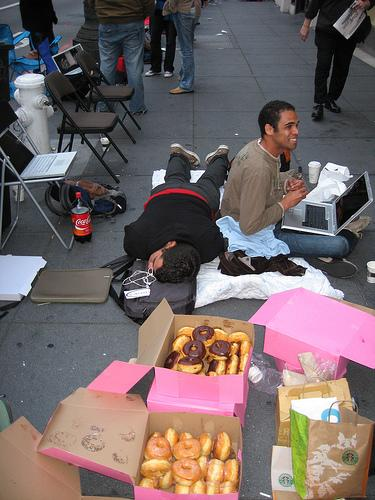How many donuts with chocolate topping are there in the image? There are six donuts with chocolate topping visible in the image. Describe the bag near the man on the sidewalk and what is on it. There is a brown paper bag near the man on the sidewalk, and it has a Starbucks label on it. What kind of device is the man sitting cross-legged using? The man sitting cross-legged is using a laptop. Identify the location and the unusual occurrence involving a man in this image. A man is seen sleeping face down on the sidewalk, which is an unusual occurrence. What type of beverage is in the brown paper sack? The brown paper sack has a Starbucks label on it, indicating that it likely contains a Starbucks beverage. What is the color and type of chair in the image, and what is placed on it? There is a black folding chair with a laptop sitting on it. Mention the color and content of the two boxes on the ground. There are two pink boxes on the ground, containing glazed and chocolate donuts. Comment on the condition of the Coca Cola bottle in the image. The Coca Cola bottle in the image is partially drank, indicating that it has been opened and consumed. What type of object is laying on the sidewalk with a gray color? A gray laptop case is laying on the sidewalk. What is the person wearing all black doing? The person wearing all black is holding a newspaper. 